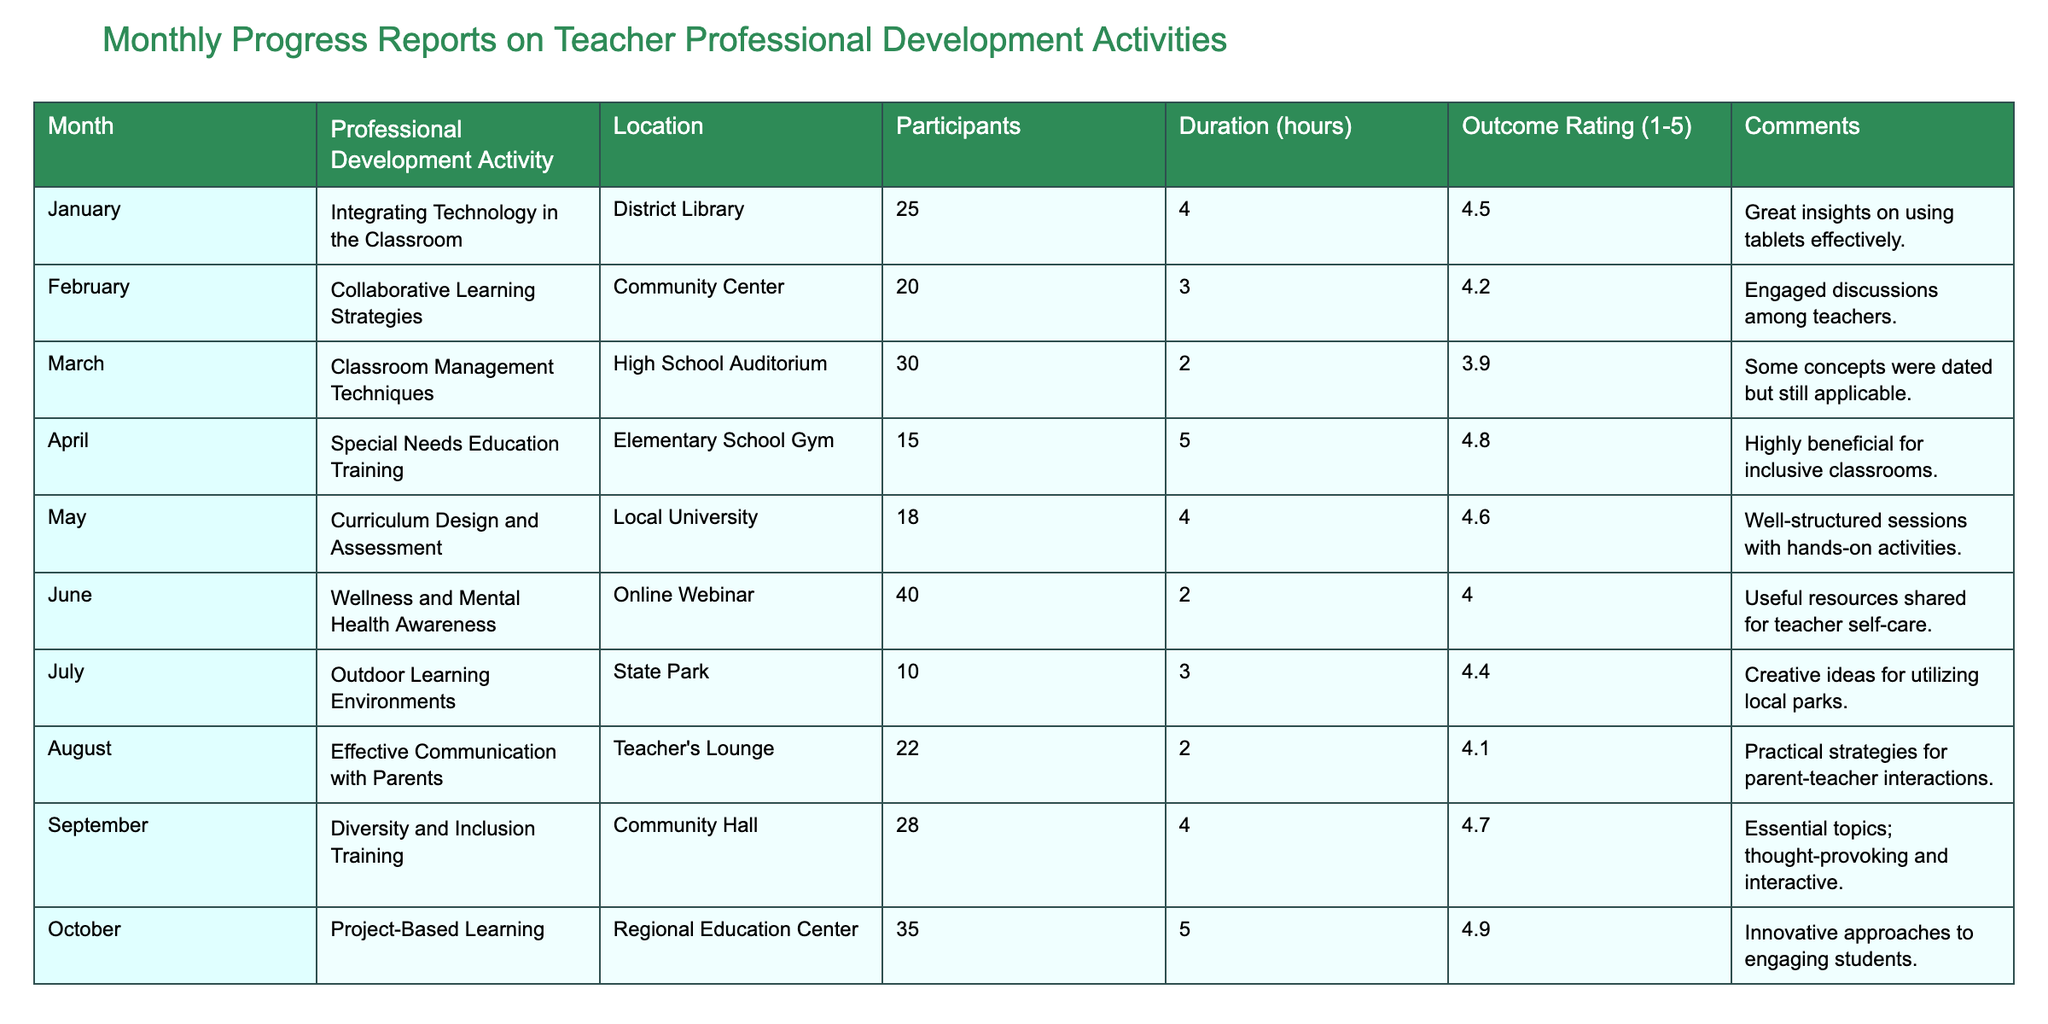What was the outcome rating for the “Classroom Management Techniques” activity? The outcome rating for “Classroom Management Techniques” in March is shown in the table as 3.
Answer: 3 Which month had the highest number of participants? In the table, by checking the number of participants for each month, October had 35 participants for the "Project-Based Learning" activity.
Answer: 35 What is the average duration of the professional development activities? To find the average duration, sum all the durations: (4 + 3 + 2 + 5 + 4 + 2 + 3 + 2 + 4 + 5) = 35 hours. Then divide by 10 (the number of activities), which gives an average of 3.5 hours.
Answer: 3.5 Did any activity receive a perfect outcome rating of 5? By scanning through the outcome ratings in the table, both the "Special Needs Education Training" in April and "Project-Based Learning" in October received perfect ratings of 5.
Answer: Yes What was the overall outcome rating for the training focused on special needs education? The outcome rating for the "Special Needs Education Training" in April is detailed in the table as 4.8.
Answer: 4.8 Which month had the lowest outcome rating, and what was it? By examining the outcome ratings, the "Classroom Management Techniques" in March had the lowest rating of 3.9.
Answer: 3.9 How many hours of professional development activities were conducted in the month of June? Referring to the table, the duration of the “Wellness and Mental Health Awareness” activity in June is indicated as 2 hours.
Answer: 2 What was the highest outcome rating recorded and for which activity? The highest outcome rating recorded in the table is 4.9, which was for the "Project-Based Learning" activity in October.
Answer: 4.9, Project-Based Learning What is the difference between the highest and lowest number of participants in a single activity? The highest number of participants is 35 from October's activity, and the lowest is 10 from July's activity. The difference is 35 - 10 = 25.
Answer: 25 